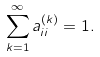<formula> <loc_0><loc_0><loc_500><loc_500>\sum _ { k = 1 } ^ { \infty } a _ { i i } ^ { ( k ) } = 1 .</formula> 